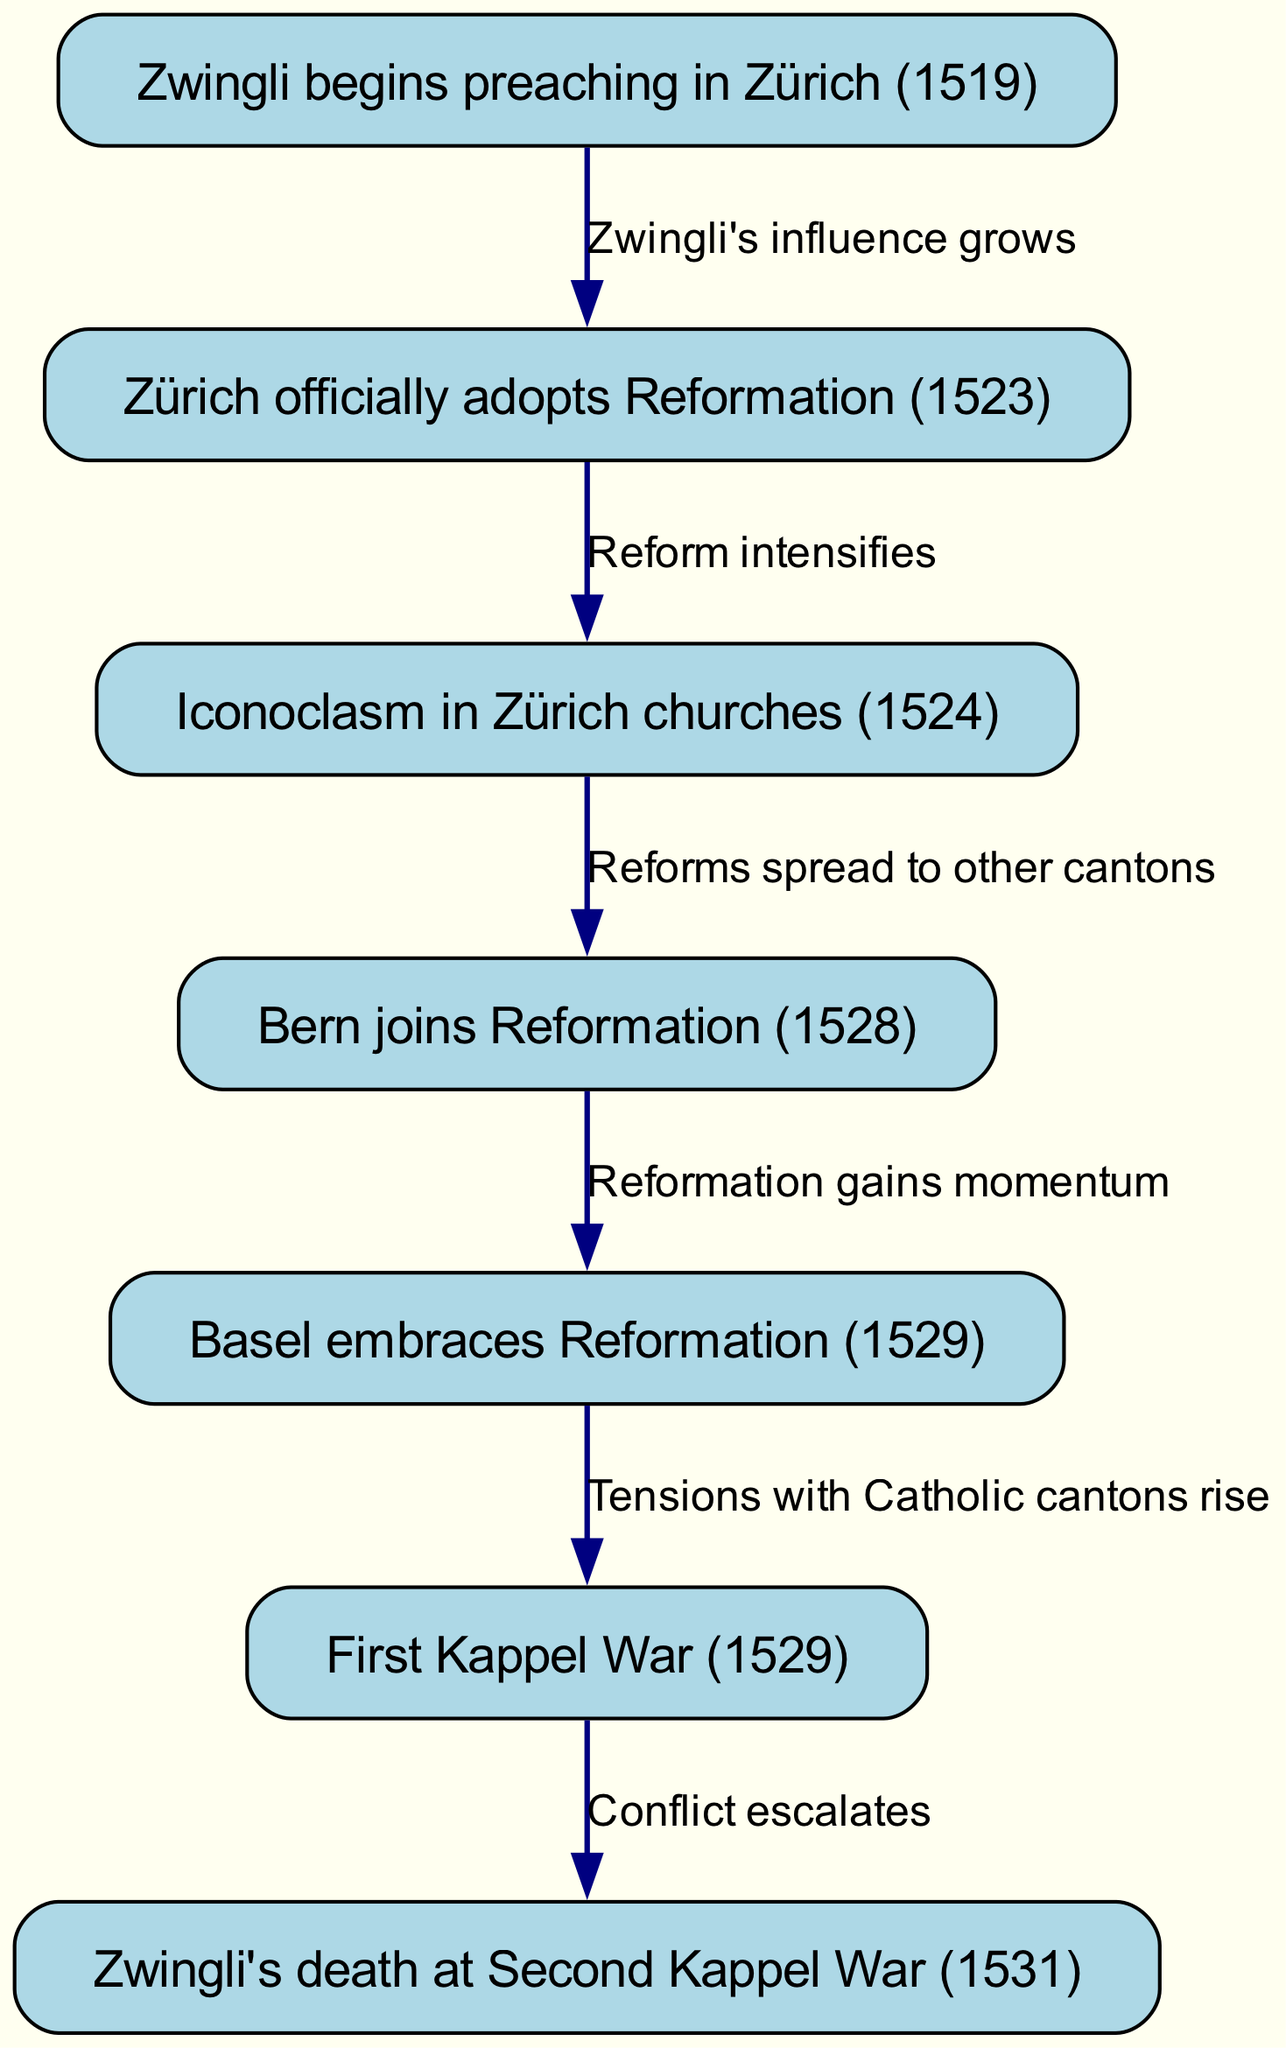What event marks the beginning of Zwingli's influence in Zürich? The diagram indicates that Zwingli begins preaching in Zürich in 1519, which is the first node in the timeline. This event sets the foundation for his subsequent influence.
Answer: Zwingli begins preaching in Zürich (1519) How many nodes are there in the diagram? By counting the individual events listed in the nodes, there are a total of 7 events outlined from Zwingli's initial preaching to his death.
Answer: 7 What was the outcome of the First Kappel War in relation to Zwingli? The edge leading from the First Kappel War (1529) to Zwingli’s death specifies that conflict escalates leading to his eventual death in the Second Kappel War. This shows a direct cause-effect relationship in the pathway.
Answer: Zwingli's death at Second Kappel War (1531) Which canton joined the Reformation in 1528? The edge connecting the node for Bern to the adoption of the Reformation shows that Bern is the canton that adopted the changes in 1528, following the developments in Zürich.
Answer: Bern joins Reformation (1528) What transition occurs from the iconoclasm in Zürich churches to the other cantons? The diagram illustrates that after the iconoclasm in Zürich churches in 1524, there is a direct progression to the spread of reforms to other cantons, indicating the influence of such actions beyond Zürich.
Answer: Reforms spread to other cantons What major event occurred in 1529 that affected tensions between cantons? The diagram points out that in 1529, the First Kappel War occurred, which heightened tensions with Catholic cantons, reflecting a growing conflict stemming from the Reformation movements.
Answer: First Kappel War (1529) What event connects Zwingli's death to the escalation of conflict? The diagram shows that Zwingli’s death at the Second Kappel War is the result of prior escalating conflicts initiated by the tensions observed during the First Kappel War.
Answer: Conflict escalates 